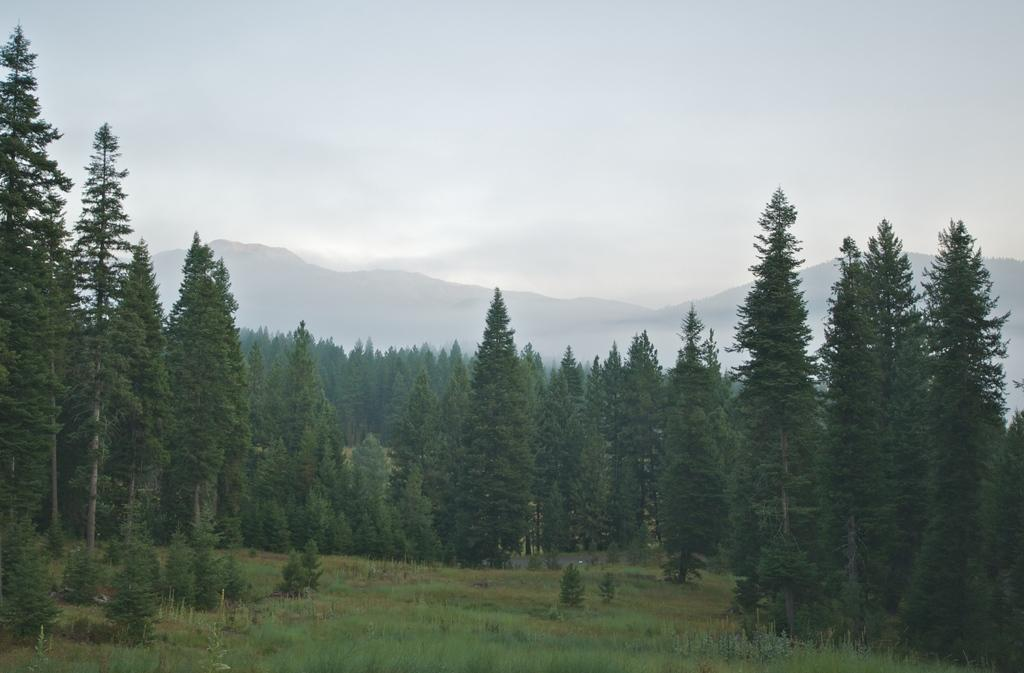What type of vegetation is present in the image? There are trees and grass in the image. What type of natural landform can be seen in the image? There are mountains in the image. What part of the natural environment is visible in the image? The sky is visible in the image. How many giants can be seen walking on the road in the image? There are no giants or roads present in the image. 